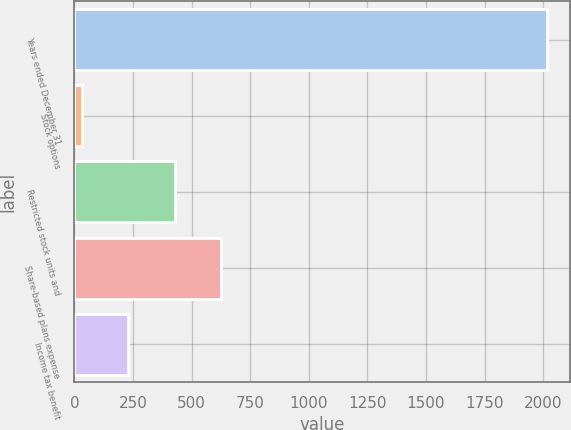Convert chart to OTSL. <chart><loc_0><loc_0><loc_500><loc_500><bar_chart><fcel>Years ended December 31<fcel>Stock options<fcel>Restricted stock units and<fcel>Share-based plans expense<fcel>Income tax benefit<nl><fcel>2015<fcel>30<fcel>427<fcel>625.5<fcel>228.5<nl></chart> 